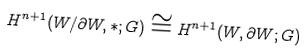Convert formula to latex. <formula><loc_0><loc_0><loc_500><loc_500>H ^ { n + 1 } ( W / \partial W , \ast ; G ) \cong H ^ { n + 1 } ( W , \partial W ; G )</formula> 